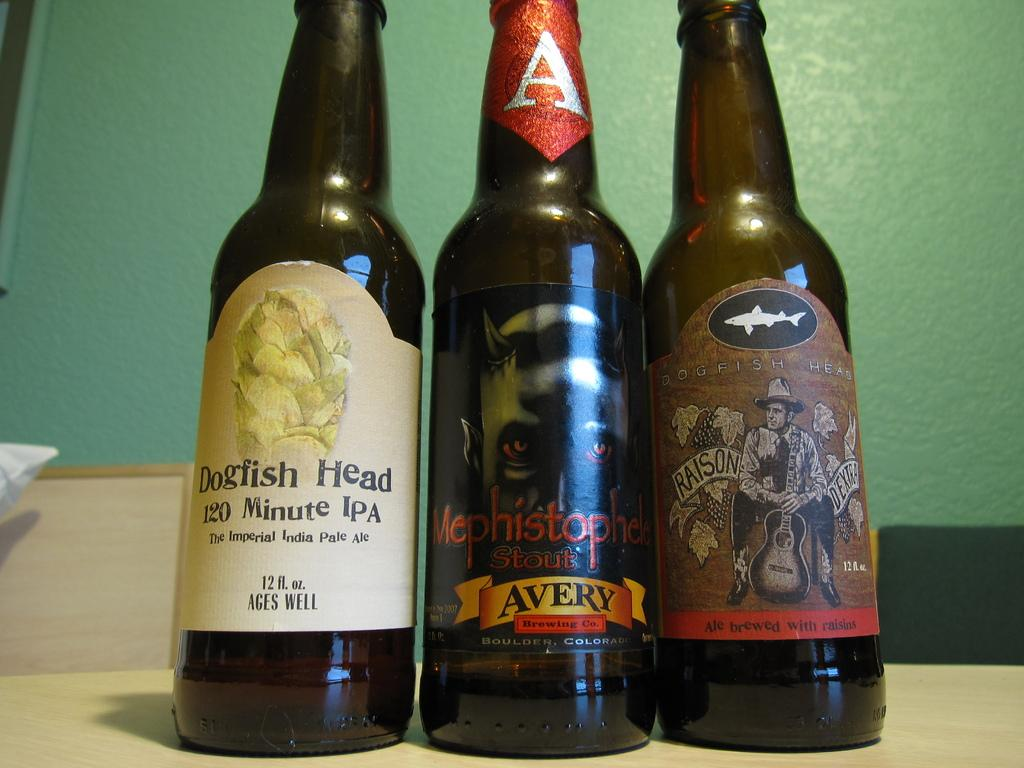<image>
Describe the image concisely. Three bottles of beer, including selections from Dogfish Head and Mephistophele. 